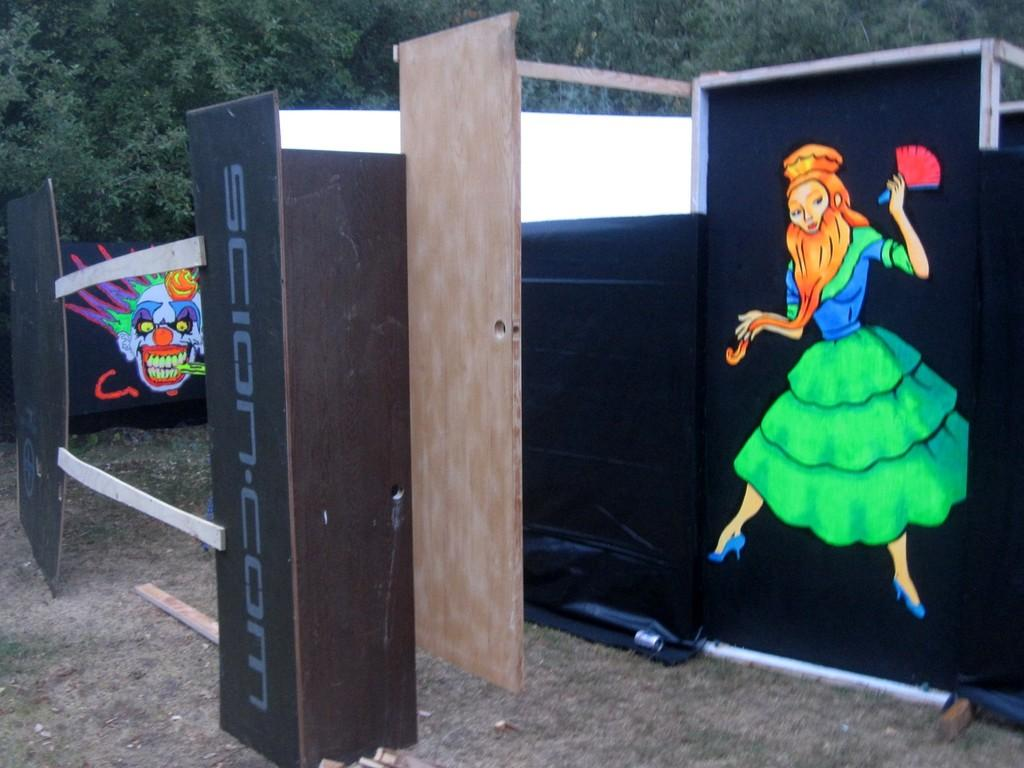What material is the object in the image made of? The object in the image is made of wood. What is featured on the wooden object? There is text and images on the wooden object. What can be seen in the background of the image? There is a tree in the image. What is present on the ground in the image? There is wood on the ground in the image. How many pickles are hanging from the tree in the image? There are no pickles present in the image; it features a wooden object with text and images, a tree in the background, and wood on the ground. What type of potato is being processed in the image? There is no potato or process related to a potato depicted in the image. 